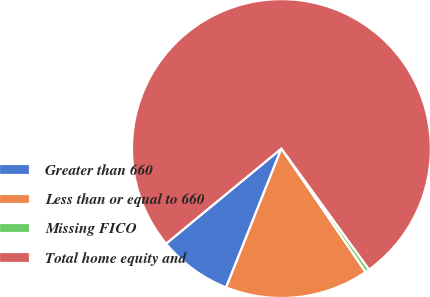<chart> <loc_0><loc_0><loc_500><loc_500><pie_chart><fcel>Greater than 660<fcel>Less than or equal to 660<fcel>Missing FICO<fcel>Total home equity and<nl><fcel>8.0%<fcel>15.56%<fcel>0.45%<fcel>75.99%<nl></chart> 